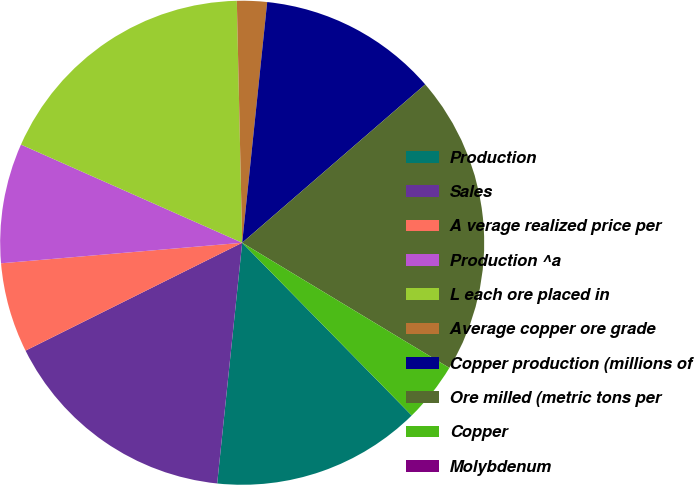Convert chart. <chart><loc_0><loc_0><loc_500><loc_500><pie_chart><fcel>Production<fcel>Sales<fcel>A verage realized price per<fcel>Production ^a<fcel>L each ore placed in<fcel>Average copper ore grade<fcel>Copper production (millions of<fcel>Ore milled (metric tons per<fcel>Copper<fcel>Molybdenum<nl><fcel>14.0%<fcel>16.0%<fcel>6.0%<fcel>8.0%<fcel>18.0%<fcel>2.0%<fcel>12.0%<fcel>20.0%<fcel>4.0%<fcel>0.0%<nl></chart> 